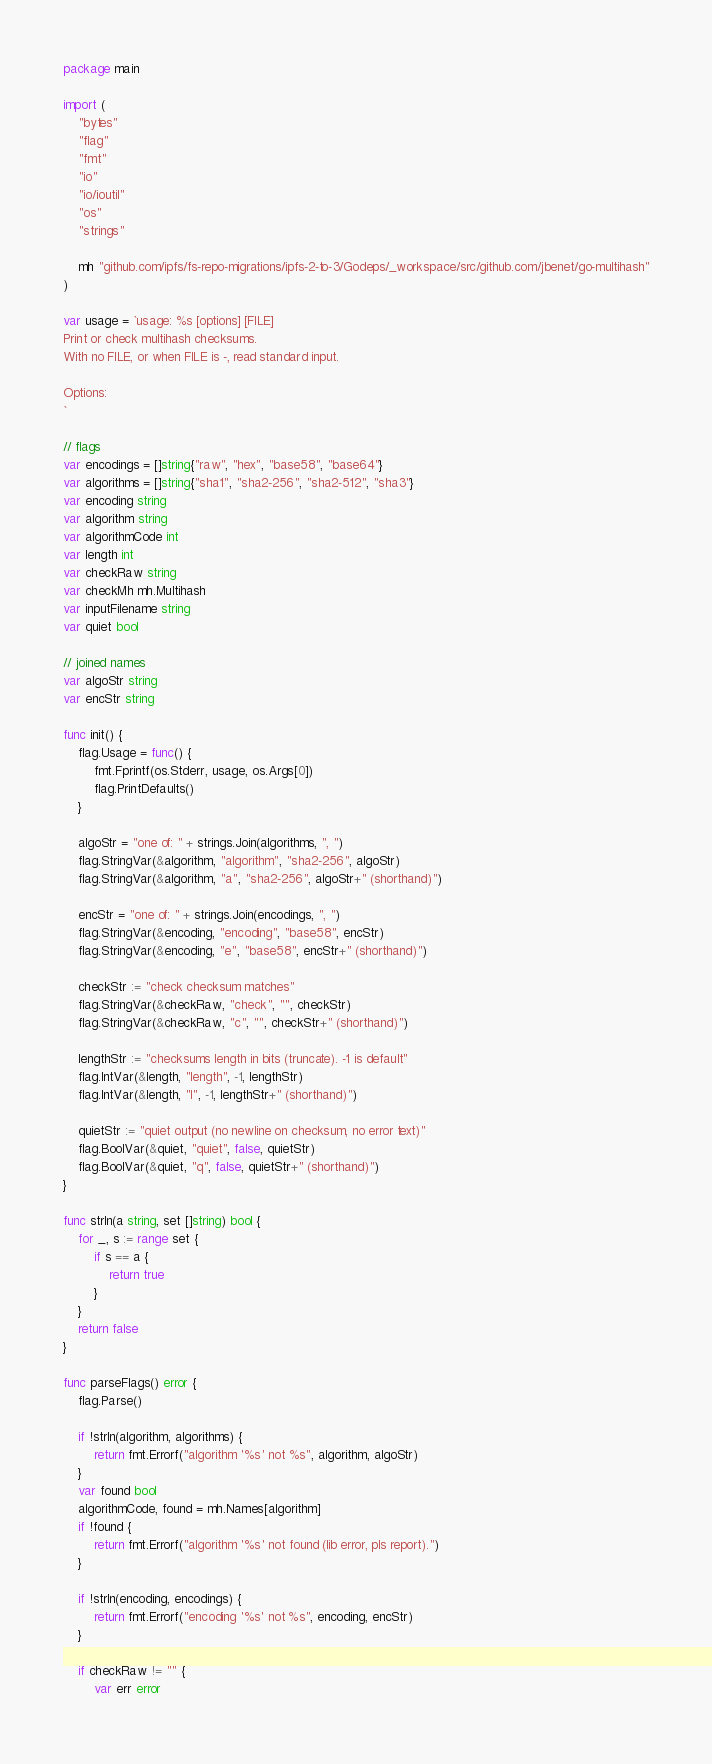<code> <loc_0><loc_0><loc_500><loc_500><_Go_>package main

import (
	"bytes"
	"flag"
	"fmt"
	"io"
	"io/ioutil"
	"os"
	"strings"

	mh "github.com/ipfs/fs-repo-migrations/ipfs-2-to-3/Godeps/_workspace/src/github.com/jbenet/go-multihash"
)

var usage = `usage: %s [options] [FILE]
Print or check multihash checksums.
With no FILE, or when FILE is -, read standard input.

Options:
`

// flags
var encodings = []string{"raw", "hex", "base58", "base64"}
var algorithms = []string{"sha1", "sha2-256", "sha2-512", "sha3"}
var encoding string
var algorithm string
var algorithmCode int
var length int
var checkRaw string
var checkMh mh.Multihash
var inputFilename string
var quiet bool

// joined names
var algoStr string
var encStr string

func init() {
	flag.Usage = func() {
		fmt.Fprintf(os.Stderr, usage, os.Args[0])
		flag.PrintDefaults()
	}

	algoStr = "one of: " + strings.Join(algorithms, ", ")
	flag.StringVar(&algorithm, "algorithm", "sha2-256", algoStr)
	flag.StringVar(&algorithm, "a", "sha2-256", algoStr+" (shorthand)")

	encStr = "one of: " + strings.Join(encodings, ", ")
	flag.StringVar(&encoding, "encoding", "base58", encStr)
	flag.StringVar(&encoding, "e", "base58", encStr+" (shorthand)")

	checkStr := "check checksum matches"
	flag.StringVar(&checkRaw, "check", "", checkStr)
	flag.StringVar(&checkRaw, "c", "", checkStr+" (shorthand)")

	lengthStr := "checksums length in bits (truncate). -1 is default"
	flag.IntVar(&length, "length", -1, lengthStr)
	flag.IntVar(&length, "l", -1, lengthStr+" (shorthand)")

	quietStr := "quiet output (no newline on checksum, no error text)"
	flag.BoolVar(&quiet, "quiet", false, quietStr)
	flag.BoolVar(&quiet, "q", false, quietStr+" (shorthand)")
}

func strIn(a string, set []string) bool {
	for _, s := range set {
		if s == a {
			return true
		}
	}
	return false
}

func parseFlags() error {
	flag.Parse()

	if !strIn(algorithm, algorithms) {
		return fmt.Errorf("algorithm '%s' not %s", algorithm, algoStr)
	}
	var found bool
	algorithmCode, found = mh.Names[algorithm]
	if !found {
		return fmt.Errorf("algorithm '%s' not found (lib error, pls report).")
	}

	if !strIn(encoding, encodings) {
		return fmt.Errorf("encoding '%s' not %s", encoding, encStr)
	}

	if checkRaw != "" {
		var err error</code> 